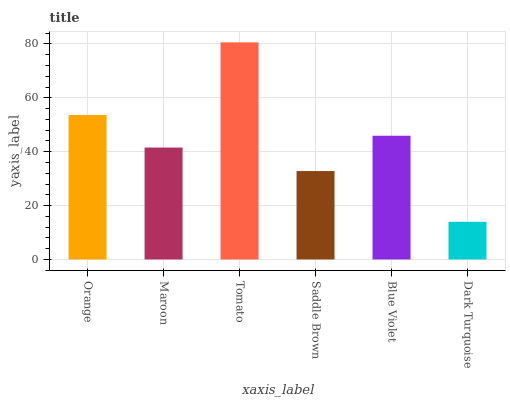Is Dark Turquoise the minimum?
Answer yes or no. Yes. Is Tomato the maximum?
Answer yes or no. Yes. Is Maroon the minimum?
Answer yes or no. No. Is Maroon the maximum?
Answer yes or no. No. Is Orange greater than Maroon?
Answer yes or no. Yes. Is Maroon less than Orange?
Answer yes or no. Yes. Is Maroon greater than Orange?
Answer yes or no. No. Is Orange less than Maroon?
Answer yes or no. No. Is Blue Violet the high median?
Answer yes or no. Yes. Is Maroon the low median?
Answer yes or no. Yes. Is Orange the high median?
Answer yes or no. No. Is Tomato the low median?
Answer yes or no. No. 